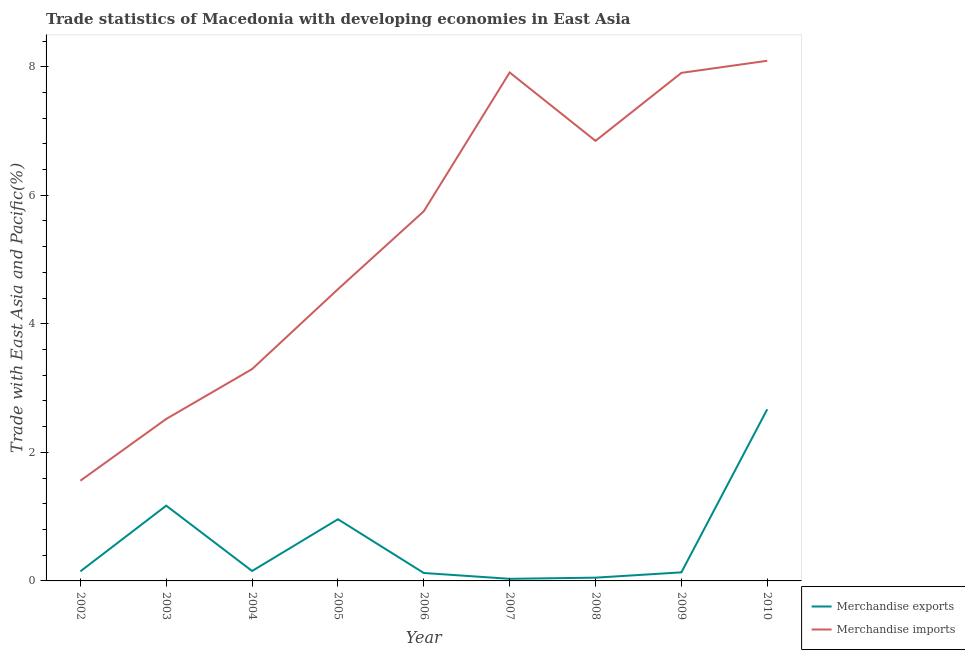How many different coloured lines are there?
Provide a short and direct response. 2. Does the line corresponding to merchandise exports intersect with the line corresponding to merchandise imports?
Your response must be concise. No. Is the number of lines equal to the number of legend labels?
Provide a succinct answer. Yes. What is the merchandise imports in 2009?
Your response must be concise. 7.9. Across all years, what is the maximum merchandise exports?
Your answer should be compact. 2.67. Across all years, what is the minimum merchandise imports?
Your answer should be compact. 1.56. In which year was the merchandise exports maximum?
Offer a terse response. 2010. What is the total merchandise exports in the graph?
Provide a succinct answer. 5.44. What is the difference between the merchandise exports in 2007 and that in 2008?
Offer a very short reply. -0.02. What is the difference between the merchandise imports in 2004 and the merchandise exports in 2010?
Provide a short and direct response. 0.62. What is the average merchandise exports per year?
Keep it short and to the point. 0.6. In the year 2009, what is the difference between the merchandise exports and merchandise imports?
Give a very brief answer. -7.77. In how many years, is the merchandise imports greater than 1.6 %?
Provide a short and direct response. 8. What is the ratio of the merchandise exports in 2004 to that in 2006?
Provide a succinct answer. 1.25. Is the merchandise imports in 2007 less than that in 2009?
Make the answer very short. No. Is the difference between the merchandise exports in 2005 and 2009 greater than the difference between the merchandise imports in 2005 and 2009?
Keep it short and to the point. Yes. What is the difference between the highest and the second highest merchandise imports?
Give a very brief answer. 0.18. What is the difference between the highest and the lowest merchandise exports?
Provide a succinct answer. 2.64. In how many years, is the merchandise imports greater than the average merchandise imports taken over all years?
Make the answer very short. 5. Is the sum of the merchandise imports in 2002 and 2010 greater than the maximum merchandise exports across all years?
Provide a succinct answer. Yes. Is the merchandise exports strictly greater than the merchandise imports over the years?
Your answer should be very brief. No. Is the merchandise exports strictly less than the merchandise imports over the years?
Your answer should be very brief. Yes. Are the values on the major ticks of Y-axis written in scientific E-notation?
Ensure brevity in your answer.  No. Does the graph contain any zero values?
Provide a succinct answer. No. Does the graph contain grids?
Your response must be concise. No. Where does the legend appear in the graph?
Give a very brief answer. Bottom right. What is the title of the graph?
Provide a succinct answer. Trade statistics of Macedonia with developing economies in East Asia. What is the label or title of the X-axis?
Make the answer very short. Year. What is the label or title of the Y-axis?
Keep it short and to the point. Trade with East Asia and Pacific(%). What is the Trade with East Asia and Pacific(%) in Merchandise exports in 2002?
Keep it short and to the point. 0.15. What is the Trade with East Asia and Pacific(%) in Merchandise imports in 2002?
Your response must be concise. 1.56. What is the Trade with East Asia and Pacific(%) of Merchandise exports in 2003?
Your response must be concise. 1.17. What is the Trade with East Asia and Pacific(%) in Merchandise imports in 2003?
Make the answer very short. 2.52. What is the Trade with East Asia and Pacific(%) of Merchandise exports in 2004?
Provide a succinct answer. 0.15. What is the Trade with East Asia and Pacific(%) in Merchandise imports in 2004?
Provide a succinct answer. 3.3. What is the Trade with East Asia and Pacific(%) in Merchandise exports in 2005?
Offer a very short reply. 0.96. What is the Trade with East Asia and Pacific(%) of Merchandise imports in 2005?
Provide a succinct answer. 4.54. What is the Trade with East Asia and Pacific(%) of Merchandise exports in 2006?
Ensure brevity in your answer.  0.12. What is the Trade with East Asia and Pacific(%) of Merchandise imports in 2006?
Provide a short and direct response. 5.75. What is the Trade with East Asia and Pacific(%) in Merchandise exports in 2007?
Keep it short and to the point. 0.03. What is the Trade with East Asia and Pacific(%) of Merchandise imports in 2007?
Provide a succinct answer. 7.91. What is the Trade with East Asia and Pacific(%) of Merchandise exports in 2008?
Ensure brevity in your answer.  0.05. What is the Trade with East Asia and Pacific(%) of Merchandise imports in 2008?
Make the answer very short. 6.85. What is the Trade with East Asia and Pacific(%) in Merchandise exports in 2009?
Keep it short and to the point. 0.13. What is the Trade with East Asia and Pacific(%) in Merchandise imports in 2009?
Your answer should be compact. 7.9. What is the Trade with East Asia and Pacific(%) in Merchandise exports in 2010?
Make the answer very short. 2.67. What is the Trade with East Asia and Pacific(%) of Merchandise imports in 2010?
Ensure brevity in your answer.  8.09. Across all years, what is the maximum Trade with East Asia and Pacific(%) in Merchandise exports?
Ensure brevity in your answer.  2.67. Across all years, what is the maximum Trade with East Asia and Pacific(%) of Merchandise imports?
Provide a short and direct response. 8.09. Across all years, what is the minimum Trade with East Asia and Pacific(%) in Merchandise exports?
Your answer should be very brief. 0.03. Across all years, what is the minimum Trade with East Asia and Pacific(%) in Merchandise imports?
Offer a terse response. 1.56. What is the total Trade with East Asia and Pacific(%) in Merchandise exports in the graph?
Provide a short and direct response. 5.44. What is the total Trade with East Asia and Pacific(%) of Merchandise imports in the graph?
Your response must be concise. 48.42. What is the difference between the Trade with East Asia and Pacific(%) of Merchandise exports in 2002 and that in 2003?
Provide a short and direct response. -1.02. What is the difference between the Trade with East Asia and Pacific(%) in Merchandise imports in 2002 and that in 2003?
Your response must be concise. -0.96. What is the difference between the Trade with East Asia and Pacific(%) in Merchandise exports in 2002 and that in 2004?
Provide a succinct answer. -0.01. What is the difference between the Trade with East Asia and Pacific(%) in Merchandise imports in 2002 and that in 2004?
Provide a short and direct response. -1.74. What is the difference between the Trade with East Asia and Pacific(%) in Merchandise exports in 2002 and that in 2005?
Make the answer very short. -0.81. What is the difference between the Trade with East Asia and Pacific(%) of Merchandise imports in 2002 and that in 2005?
Provide a short and direct response. -2.98. What is the difference between the Trade with East Asia and Pacific(%) of Merchandise exports in 2002 and that in 2006?
Offer a very short reply. 0.03. What is the difference between the Trade with East Asia and Pacific(%) of Merchandise imports in 2002 and that in 2006?
Offer a terse response. -4.19. What is the difference between the Trade with East Asia and Pacific(%) of Merchandise exports in 2002 and that in 2007?
Keep it short and to the point. 0.12. What is the difference between the Trade with East Asia and Pacific(%) in Merchandise imports in 2002 and that in 2007?
Provide a short and direct response. -6.35. What is the difference between the Trade with East Asia and Pacific(%) of Merchandise exports in 2002 and that in 2008?
Ensure brevity in your answer.  0.1. What is the difference between the Trade with East Asia and Pacific(%) of Merchandise imports in 2002 and that in 2008?
Ensure brevity in your answer.  -5.29. What is the difference between the Trade with East Asia and Pacific(%) of Merchandise exports in 2002 and that in 2009?
Offer a terse response. 0.02. What is the difference between the Trade with East Asia and Pacific(%) of Merchandise imports in 2002 and that in 2009?
Ensure brevity in your answer.  -6.35. What is the difference between the Trade with East Asia and Pacific(%) in Merchandise exports in 2002 and that in 2010?
Offer a very short reply. -2.52. What is the difference between the Trade with East Asia and Pacific(%) in Merchandise imports in 2002 and that in 2010?
Keep it short and to the point. -6.53. What is the difference between the Trade with East Asia and Pacific(%) in Merchandise exports in 2003 and that in 2004?
Your response must be concise. 1.02. What is the difference between the Trade with East Asia and Pacific(%) of Merchandise imports in 2003 and that in 2004?
Your response must be concise. -0.78. What is the difference between the Trade with East Asia and Pacific(%) of Merchandise exports in 2003 and that in 2005?
Make the answer very short. 0.21. What is the difference between the Trade with East Asia and Pacific(%) of Merchandise imports in 2003 and that in 2005?
Make the answer very short. -2.02. What is the difference between the Trade with East Asia and Pacific(%) of Merchandise exports in 2003 and that in 2006?
Make the answer very short. 1.05. What is the difference between the Trade with East Asia and Pacific(%) in Merchandise imports in 2003 and that in 2006?
Provide a short and direct response. -3.23. What is the difference between the Trade with East Asia and Pacific(%) in Merchandise exports in 2003 and that in 2007?
Offer a very short reply. 1.14. What is the difference between the Trade with East Asia and Pacific(%) in Merchandise imports in 2003 and that in 2007?
Ensure brevity in your answer.  -5.39. What is the difference between the Trade with East Asia and Pacific(%) in Merchandise exports in 2003 and that in 2008?
Make the answer very short. 1.12. What is the difference between the Trade with East Asia and Pacific(%) of Merchandise imports in 2003 and that in 2008?
Your answer should be very brief. -4.33. What is the difference between the Trade with East Asia and Pacific(%) in Merchandise exports in 2003 and that in 2009?
Offer a terse response. 1.04. What is the difference between the Trade with East Asia and Pacific(%) in Merchandise imports in 2003 and that in 2009?
Ensure brevity in your answer.  -5.38. What is the difference between the Trade with East Asia and Pacific(%) of Merchandise exports in 2003 and that in 2010?
Keep it short and to the point. -1.5. What is the difference between the Trade with East Asia and Pacific(%) of Merchandise imports in 2003 and that in 2010?
Ensure brevity in your answer.  -5.57. What is the difference between the Trade with East Asia and Pacific(%) of Merchandise exports in 2004 and that in 2005?
Provide a short and direct response. -0.81. What is the difference between the Trade with East Asia and Pacific(%) of Merchandise imports in 2004 and that in 2005?
Give a very brief answer. -1.24. What is the difference between the Trade with East Asia and Pacific(%) in Merchandise exports in 2004 and that in 2006?
Provide a succinct answer. 0.03. What is the difference between the Trade with East Asia and Pacific(%) of Merchandise imports in 2004 and that in 2006?
Your response must be concise. -2.46. What is the difference between the Trade with East Asia and Pacific(%) in Merchandise exports in 2004 and that in 2007?
Provide a short and direct response. 0.12. What is the difference between the Trade with East Asia and Pacific(%) of Merchandise imports in 2004 and that in 2007?
Ensure brevity in your answer.  -4.61. What is the difference between the Trade with East Asia and Pacific(%) of Merchandise exports in 2004 and that in 2008?
Give a very brief answer. 0.1. What is the difference between the Trade with East Asia and Pacific(%) in Merchandise imports in 2004 and that in 2008?
Offer a terse response. -3.55. What is the difference between the Trade with East Asia and Pacific(%) of Merchandise exports in 2004 and that in 2009?
Ensure brevity in your answer.  0.02. What is the difference between the Trade with East Asia and Pacific(%) of Merchandise imports in 2004 and that in 2009?
Your answer should be very brief. -4.61. What is the difference between the Trade with East Asia and Pacific(%) of Merchandise exports in 2004 and that in 2010?
Make the answer very short. -2.52. What is the difference between the Trade with East Asia and Pacific(%) in Merchandise imports in 2004 and that in 2010?
Keep it short and to the point. -4.8. What is the difference between the Trade with East Asia and Pacific(%) of Merchandise exports in 2005 and that in 2006?
Offer a terse response. 0.84. What is the difference between the Trade with East Asia and Pacific(%) in Merchandise imports in 2005 and that in 2006?
Give a very brief answer. -1.21. What is the difference between the Trade with East Asia and Pacific(%) of Merchandise exports in 2005 and that in 2007?
Ensure brevity in your answer.  0.93. What is the difference between the Trade with East Asia and Pacific(%) in Merchandise imports in 2005 and that in 2007?
Keep it short and to the point. -3.37. What is the difference between the Trade with East Asia and Pacific(%) of Merchandise exports in 2005 and that in 2008?
Your answer should be compact. 0.91. What is the difference between the Trade with East Asia and Pacific(%) of Merchandise imports in 2005 and that in 2008?
Give a very brief answer. -2.31. What is the difference between the Trade with East Asia and Pacific(%) of Merchandise exports in 2005 and that in 2009?
Your answer should be compact. 0.83. What is the difference between the Trade with East Asia and Pacific(%) in Merchandise imports in 2005 and that in 2009?
Give a very brief answer. -3.37. What is the difference between the Trade with East Asia and Pacific(%) in Merchandise exports in 2005 and that in 2010?
Offer a terse response. -1.71. What is the difference between the Trade with East Asia and Pacific(%) in Merchandise imports in 2005 and that in 2010?
Provide a succinct answer. -3.55. What is the difference between the Trade with East Asia and Pacific(%) in Merchandise exports in 2006 and that in 2007?
Provide a short and direct response. 0.09. What is the difference between the Trade with East Asia and Pacific(%) of Merchandise imports in 2006 and that in 2007?
Keep it short and to the point. -2.16. What is the difference between the Trade with East Asia and Pacific(%) in Merchandise exports in 2006 and that in 2008?
Ensure brevity in your answer.  0.07. What is the difference between the Trade with East Asia and Pacific(%) of Merchandise imports in 2006 and that in 2008?
Your response must be concise. -1.1. What is the difference between the Trade with East Asia and Pacific(%) of Merchandise exports in 2006 and that in 2009?
Give a very brief answer. -0.01. What is the difference between the Trade with East Asia and Pacific(%) in Merchandise imports in 2006 and that in 2009?
Offer a terse response. -2.15. What is the difference between the Trade with East Asia and Pacific(%) of Merchandise exports in 2006 and that in 2010?
Keep it short and to the point. -2.55. What is the difference between the Trade with East Asia and Pacific(%) of Merchandise imports in 2006 and that in 2010?
Your answer should be compact. -2.34. What is the difference between the Trade with East Asia and Pacific(%) in Merchandise exports in 2007 and that in 2008?
Offer a very short reply. -0.02. What is the difference between the Trade with East Asia and Pacific(%) in Merchandise imports in 2007 and that in 2008?
Give a very brief answer. 1.06. What is the difference between the Trade with East Asia and Pacific(%) in Merchandise exports in 2007 and that in 2009?
Keep it short and to the point. -0.1. What is the difference between the Trade with East Asia and Pacific(%) of Merchandise imports in 2007 and that in 2009?
Provide a short and direct response. 0.01. What is the difference between the Trade with East Asia and Pacific(%) of Merchandise exports in 2007 and that in 2010?
Provide a short and direct response. -2.64. What is the difference between the Trade with East Asia and Pacific(%) of Merchandise imports in 2007 and that in 2010?
Your answer should be compact. -0.18. What is the difference between the Trade with East Asia and Pacific(%) of Merchandise exports in 2008 and that in 2009?
Offer a very short reply. -0.08. What is the difference between the Trade with East Asia and Pacific(%) of Merchandise imports in 2008 and that in 2009?
Your response must be concise. -1.06. What is the difference between the Trade with East Asia and Pacific(%) in Merchandise exports in 2008 and that in 2010?
Offer a terse response. -2.62. What is the difference between the Trade with East Asia and Pacific(%) of Merchandise imports in 2008 and that in 2010?
Your answer should be very brief. -1.25. What is the difference between the Trade with East Asia and Pacific(%) of Merchandise exports in 2009 and that in 2010?
Your answer should be compact. -2.54. What is the difference between the Trade with East Asia and Pacific(%) in Merchandise imports in 2009 and that in 2010?
Your response must be concise. -0.19. What is the difference between the Trade with East Asia and Pacific(%) in Merchandise exports in 2002 and the Trade with East Asia and Pacific(%) in Merchandise imports in 2003?
Offer a very short reply. -2.37. What is the difference between the Trade with East Asia and Pacific(%) in Merchandise exports in 2002 and the Trade with East Asia and Pacific(%) in Merchandise imports in 2004?
Your answer should be compact. -3.15. What is the difference between the Trade with East Asia and Pacific(%) of Merchandise exports in 2002 and the Trade with East Asia and Pacific(%) of Merchandise imports in 2005?
Provide a short and direct response. -4.39. What is the difference between the Trade with East Asia and Pacific(%) in Merchandise exports in 2002 and the Trade with East Asia and Pacific(%) in Merchandise imports in 2006?
Offer a terse response. -5.6. What is the difference between the Trade with East Asia and Pacific(%) of Merchandise exports in 2002 and the Trade with East Asia and Pacific(%) of Merchandise imports in 2007?
Give a very brief answer. -7.76. What is the difference between the Trade with East Asia and Pacific(%) of Merchandise exports in 2002 and the Trade with East Asia and Pacific(%) of Merchandise imports in 2008?
Offer a very short reply. -6.7. What is the difference between the Trade with East Asia and Pacific(%) in Merchandise exports in 2002 and the Trade with East Asia and Pacific(%) in Merchandise imports in 2009?
Offer a terse response. -7.76. What is the difference between the Trade with East Asia and Pacific(%) in Merchandise exports in 2002 and the Trade with East Asia and Pacific(%) in Merchandise imports in 2010?
Keep it short and to the point. -7.94. What is the difference between the Trade with East Asia and Pacific(%) in Merchandise exports in 2003 and the Trade with East Asia and Pacific(%) in Merchandise imports in 2004?
Your answer should be very brief. -2.12. What is the difference between the Trade with East Asia and Pacific(%) in Merchandise exports in 2003 and the Trade with East Asia and Pacific(%) in Merchandise imports in 2005?
Keep it short and to the point. -3.37. What is the difference between the Trade with East Asia and Pacific(%) in Merchandise exports in 2003 and the Trade with East Asia and Pacific(%) in Merchandise imports in 2006?
Keep it short and to the point. -4.58. What is the difference between the Trade with East Asia and Pacific(%) in Merchandise exports in 2003 and the Trade with East Asia and Pacific(%) in Merchandise imports in 2007?
Your response must be concise. -6.74. What is the difference between the Trade with East Asia and Pacific(%) in Merchandise exports in 2003 and the Trade with East Asia and Pacific(%) in Merchandise imports in 2008?
Give a very brief answer. -5.68. What is the difference between the Trade with East Asia and Pacific(%) in Merchandise exports in 2003 and the Trade with East Asia and Pacific(%) in Merchandise imports in 2009?
Your answer should be very brief. -6.73. What is the difference between the Trade with East Asia and Pacific(%) in Merchandise exports in 2003 and the Trade with East Asia and Pacific(%) in Merchandise imports in 2010?
Provide a short and direct response. -6.92. What is the difference between the Trade with East Asia and Pacific(%) of Merchandise exports in 2004 and the Trade with East Asia and Pacific(%) of Merchandise imports in 2005?
Your answer should be very brief. -4.38. What is the difference between the Trade with East Asia and Pacific(%) in Merchandise exports in 2004 and the Trade with East Asia and Pacific(%) in Merchandise imports in 2006?
Give a very brief answer. -5.6. What is the difference between the Trade with East Asia and Pacific(%) in Merchandise exports in 2004 and the Trade with East Asia and Pacific(%) in Merchandise imports in 2007?
Provide a short and direct response. -7.76. What is the difference between the Trade with East Asia and Pacific(%) in Merchandise exports in 2004 and the Trade with East Asia and Pacific(%) in Merchandise imports in 2008?
Offer a terse response. -6.69. What is the difference between the Trade with East Asia and Pacific(%) in Merchandise exports in 2004 and the Trade with East Asia and Pacific(%) in Merchandise imports in 2009?
Your answer should be compact. -7.75. What is the difference between the Trade with East Asia and Pacific(%) in Merchandise exports in 2004 and the Trade with East Asia and Pacific(%) in Merchandise imports in 2010?
Provide a succinct answer. -7.94. What is the difference between the Trade with East Asia and Pacific(%) of Merchandise exports in 2005 and the Trade with East Asia and Pacific(%) of Merchandise imports in 2006?
Your answer should be very brief. -4.79. What is the difference between the Trade with East Asia and Pacific(%) in Merchandise exports in 2005 and the Trade with East Asia and Pacific(%) in Merchandise imports in 2007?
Offer a very short reply. -6.95. What is the difference between the Trade with East Asia and Pacific(%) of Merchandise exports in 2005 and the Trade with East Asia and Pacific(%) of Merchandise imports in 2008?
Ensure brevity in your answer.  -5.89. What is the difference between the Trade with East Asia and Pacific(%) of Merchandise exports in 2005 and the Trade with East Asia and Pacific(%) of Merchandise imports in 2009?
Your answer should be compact. -6.94. What is the difference between the Trade with East Asia and Pacific(%) of Merchandise exports in 2005 and the Trade with East Asia and Pacific(%) of Merchandise imports in 2010?
Give a very brief answer. -7.13. What is the difference between the Trade with East Asia and Pacific(%) of Merchandise exports in 2006 and the Trade with East Asia and Pacific(%) of Merchandise imports in 2007?
Provide a short and direct response. -7.79. What is the difference between the Trade with East Asia and Pacific(%) of Merchandise exports in 2006 and the Trade with East Asia and Pacific(%) of Merchandise imports in 2008?
Your answer should be compact. -6.72. What is the difference between the Trade with East Asia and Pacific(%) of Merchandise exports in 2006 and the Trade with East Asia and Pacific(%) of Merchandise imports in 2009?
Ensure brevity in your answer.  -7.78. What is the difference between the Trade with East Asia and Pacific(%) in Merchandise exports in 2006 and the Trade with East Asia and Pacific(%) in Merchandise imports in 2010?
Your answer should be compact. -7.97. What is the difference between the Trade with East Asia and Pacific(%) of Merchandise exports in 2007 and the Trade with East Asia and Pacific(%) of Merchandise imports in 2008?
Your response must be concise. -6.81. What is the difference between the Trade with East Asia and Pacific(%) in Merchandise exports in 2007 and the Trade with East Asia and Pacific(%) in Merchandise imports in 2009?
Ensure brevity in your answer.  -7.87. What is the difference between the Trade with East Asia and Pacific(%) of Merchandise exports in 2007 and the Trade with East Asia and Pacific(%) of Merchandise imports in 2010?
Make the answer very short. -8.06. What is the difference between the Trade with East Asia and Pacific(%) in Merchandise exports in 2008 and the Trade with East Asia and Pacific(%) in Merchandise imports in 2009?
Ensure brevity in your answer.  -7.85. What is the difference between the Trade with East Asia and Pacific(%) of Merchandise exports in 2008 and the Trade with East Asia and Pacific(%) of Merchandise imports in 2010?
Provide a short and direct response. -8.04. What is the difference between the Trade with East Asia and Pacific(%) of Merchandise exports in 2009 and the Trade with East Asia and Pacific(%) of Merchandise imports in 2010?
Keep it short and to the point. -7.96. What is the average Trade with East Asia and Pacific(%) in Merchandise exports per year?
Your answer should be compact. 0.6. What is the average Trade with East Asia and Pacific(%) in Merchandise imports per year?
Provide a short and direct response. 5.38. In the year 2002, what is the difference between the Trade with East Asia and Pacific(%) of Merchandise exports and Trade with East Asia and Pacific(%) of Merchandise imports?
Provide a short and direct response. -1.41. In the year 2003, what is the difference between the Trade with East Asia and Pacific(%) of Merchandise exports and Trade with East Asia and Pacific(%) of Merchandise imports?
Offer a very short reply. -1.35. In the year 2004, what is the difference between the Trade with East Asia and Pacific(%) in Merchandise exports and Trade with East Asia and Pacific(%) in Merchandise imports?
Ensure brevity in your answer.  -3.14. In the year 2005, what is the difference between the Trade with East Asia and Pacific(%) in Merchandise exports and Trade with East Asia and Pacific(%) in Merchandise imports?
Your answer should be compact. -3.58. In the year 2006, what is the difference between the Trade with East Asia and Pacific(%) of Merchandise exports and Trade with East Asia and Pacific(%) of Merchandise imports?
Provide a short and direct response. -5.63. In the year 2007, what is the difference between the Trade with East Asia and Pacific(%) in Merchandise exports and Trade with East Asia and Pacific(%) in Merchandise imports?
Your answer should be very brief. -7.88. In the year 2008, what is the difference between the Trade with East Asia and Pacific(%) of Merchandise exports and Trade with East Asia and Pacific(%) of Merchandise imports?
Your answer should be very brief. -6.8. In the year 2009, what is the difference between the Trade with East Asia and Pacific(%) of Merchandise exports and Trade with East Asia and Pacific(%) of Merchandise imports?
Offer a terse response. -7.77. In the year 2010, what is the difference between the Trade with East Asia and Pacific(%) of Merchandise exports and Trade with East Asia and Pacific(%) of Merchandise imports?
Offer a terse response. -5.42. What is the ratio of the Trade with East Asia and Pacific(%) of Merchandise exports in 2002 to that in 2003?
Ensure brevity in your answer.  0.13. What is the ratio of the Trade with East Asia and Pacific(%) in Merchandise imports in 2002 to that in 2003?
Your answer should be compact. 0.62. What is the ratio of the Trade with East Asia and Pacific(%) in Merchandise exports in 2002 to that in 2004?
Offer a very short reply. 0.96. What is the ratio of the Trade with East Asia and Pacific(%) of Merchandise imports in 2002 to that in 2004?
Provide a short and direct response. 0.47. What is the ratio of the Trade with East Asia and Pacific(%) of Merchandise exports in 2002 to that in 2005?
Your response must be concise. 0.15. What is the ratio of the Trade with East Asia and Pacific(%) in Merchandise imports in 2002 to that in 2005?
Give a very brief answer. 0.34. What is the ratio of the Trade with East Asia and Pacific(%) in Merchandise exports in 2002 to that in 2006?
Ensure brevity in your answer.  1.21. What is the ratio of the Trade with East Asia and Pacific(%) of Merchandise imports in 2002 to that in 2006?
Your response must be concise. 0.27. What is the ratio of the Trade with East Asia and Pacific(%) in Merchandise exports in 2002 to that in 2007?
Your answer should be compact. 4.54. What is the ratio of the Trade with East Asia and Pacific(%) of Merchandise imports in 2002 to that in 2007?
Ensure brevity in your answer.  0.2. What is the ratio of the Trade with East Asia and Pacific(%) of Merchandise exports in 2002 to that in 2008?
Ensure brevity in your answer.  2.92. What is the ratio of the Trade with East Asia and Pacific(%) in Merchandise imports in 2002 to that in 2008?
Provide a succinct answer. 0.23. What is the ratio of the Trade with East Asia and Pacific(%) in Merchandise exports in 2002 to that in 2009?
Your response must be concise. 1.12. What is the ratio of the Trade with East Asia and Pacific(%) in Merchandise imports in 2002 to that in 2009?
Provide a short and direct response. 0.2. What is the ratio of the Trade with East Asia and Pacific(%) of Merchandise exports in 2002 to that in 2010?
Give a very brief answer. 0.06. What is the ratio of the Trade with East Asia and Pacific(%) of Merchandise imports in 2002 to that in 2010?
Give a very brief answer. 0.19. What is the ratio of the Trade with East Asia and Pacific(%) in Merchandise exports in 2003 to that in 2004?
Offer a terse response. 7.58. What is the ratio of the Trade with East Asia and Pacific(%) of Merchandise imports in 2003 to that in 2004?
Provide a succinct answer. 0.76. What is the ratio of the Trade with East Asia and Pacific(%) in Merchandise exports in 2003 to that in 2005?
Your answer should be compact. 1.22. What is the ratio of the Trade with East Asia and Pacific(%) in Merchandise imports in 2003 to that in 2005?
Make the answer very short. 0.56. What is the ratio of the Trade with East Asia and Pacific(%) in Merchandise exports in 2003 to that in 2006?
Provide a short and direct response. 9.49. What is the ratio of the Trade with East Asia and Pacific(%) in Merchandise imports in 2003 to that in 2006?
Offer a terse response. 0.44. What is the ratio of the Trade with East Asia and Pacific(%) of Merchandise exports in 2003 to that in 2007?
Your response must be concise. 35.77. What is the ratio of the Trade with East Asia and Pacific(%) in Merchandise imports in 2003 to that in 2007?
Provide a short and direct response. 0.32. What is the ratio of the Trade with East Asia and Pacific(%) in Merchandise exports in 2003 to that in 2008?
Your answer should be compact. 23.03. What is the ratio of the Trade with East Asia and Pacific(%) in Merchandise imports in 2003 to that in 2008?
Your response must be concise. 0.37. What is the ratio of the Trade with East Asia and Pacific(%) of Merchandise exports in 2003 to that in 2009?
Ensure brevity in your answer.  8.79. What is the ratio of the Trade with East Asia and Pacific(%) of Merchandise imports in 2003 to that in 2009?
Make the answer very short. 0.32. What is the ratio of the Trade with East Asia and Pacific(%) in Merchandise exports in 2003 to that in 2010?
Keep it short and to the point. 0.44. What is the ratio of the Trade with East Asia and Pacific(%) in Merchandise imports in 2003 to that in 2010?
Offer a terse response. 0.31. What is the ratio of the Trade with East Asia and Pacific(%) in Merchandise exports in 2004 to that in 2005?
Your answer should be compact. 0.16. What is the ratio of the Trade with East Asia and Pacific(%) in Merchandise imports in 2004 to that in 2005?
Ensure brevity in your answer.  0.73. What is the ratio of the Trade with East Asia and Pacific(%) in Merchandise exports in 2004 to that in 2006?
Offer a very short reply. 1.25. What is the ratio of the Trade with East Asia and Pacific(%) of Merchandise imports in 2004 to that in 2006?
Ensure brevity in your answer.  0.57. What is the ratio of the Trade with East Asia and Pacific(%) of Merchandise exports in 2004 to that in 2007?
Offer a terse response. 4.72. What is the ratio of the Trade with East Asia and Pacific(%) in Merchandise imports in 2004 to that in 2007?
Your response must be concise. 0.42. What is the ratio of the Trade with East Asia and Pacific(%) of Merchandise exports in 2004 to that in 2008?
Your answer should be compact. 3.04. What is the ratio of the Trade with East Asia and Pacific(%) in Merchandise imports in 2004 to that in 2008?
Provide a succinct answer. 0.48. What is the ratio of the Trade with East Asia and Pacific(%) in Merchandise exports in 2004 to that in 2009?
Offer a very short reply. 1.16. What is the ratio of the Trade with East Asia and Pacific(%) of Merchandise imports in 2004 to that in 2009?
Your answer should be compact. 0.42. What is the ratio of the Trade with East Asia and Pacific(%) in Merchandise exports in 2004 to that in 2010?
Give a very brief answer. 0.06. What is the ratio of the Trade with East Asia and Pacific(%) of Merchandise imports in 2004 to that in 2010?
Offer a terse response. 0.41. What is the ratio of the Trade with East Asia and Pacific(%) of Merchandise exports in 2005 to that in 2006?
Your answer should be compact. 7.78. What is the ratio of the Trade with East Asia and Pacific(%) of Merchandise imports in 2005 to that in 2006?
Provide a short and direct response. 0.79. What is the ratio of the Trade with East Asia and Pacific(%) in Merchandise exports in 2005 to that in 2007?
Ensure brevity in your answer.  29.32. What is the ratio of the Trade with East Asia and Pacific(%) of Merchandise imports in 2005 to that in 2007?
Provide a short and direct response. 0.57. What is the ratio of the Trade with East Asia and Pacific(%) of Merchandise exports in 2005 to that in 2008?
Your answer should be very brief. 18.87. What is the ratio of the Trade with East Asia and Pacific(%) of Merchandise imports in 2005 to that in 2008?
Your response must be concise. 0.66. What is the ratio of the Trade with East Asia and Pacific(%) in Merchandise exports in 2005 to that in 2009?
Your answer should be very brief. 7.2. What is the ratio of the Trade with East Asia and Pacific(%) of Merchandise imports in 2005 to that in 2009?
Give a very brief answer. 0.57. What is the ratio of the Trade with East Asia and Pacific(%) in Merchandise exports in 2005 to that in 2010?
Make the answer very short. 0.36. What is the ratio of the Trade with East Asia and Pacific(%) of Merchandise imports in 2005 to that in 2010?
Your answer should be very brief. 0.56. What is the ratio of the Trade with East Asia and Pacific(%) of Merchandise exports in 2006 to that in 2007?
Your answer should be compact. 3.77. What is the ratio of the Trade with East Asia and Pacific(%) of Merchandise imports in 2006 to that in 2007?
Keep it short and to the point. 0.73. What is the ratio of the Trade with East Asia and Pacific(%) in Merchandise exports in 2006 to that in 2008?
Your answer should be compact. 2.43. What is the ratio of the Trade with East Asia and Pacific(%) in Merchandise imports in 2006 to that in 2008?
Offer a terse response. 0.84. What is the ratio of the Trade with East Asia and Pacific(%) in Merchandise exports in 2006 to that in 2009?
Ensure brevity in your answer.  0.93. What is the ratio of the Trade with East Asia and Pacific(%) in Merchandise imports in 2006 to that in 2009?
Ensure brevity in your answer.  0.73. What is the ratio of the Trade with East Asia and Pacific(%) of Merchandise exports in 2006 to that in 2010?
Offer a very short reply. 0.05. What is the ratio of the Trade with East Asia and Pacific(%) of Merchandise imports in 2006 to that in 2010?
Your response must be concise. 0.71. What is the ratio of the Trade with East Asia and Pacific(%) of Merchandise exports in 2007 to that in 2008?
Your answer should be compact. 0.64. What is the ratio of the Trade with East Asia and Pacific(%) in Merchandise imports in 2007 to that in 2008?
Ensure brevity in your answer.  1.16. What is the ratio of the Trade with East Asia and Pacific(%) of Merchandise exports in 2007 to that in 2009?
Provide a short and direct response. 0.25. What is the ratio of the Trade with East Asia and Pacific(%) of Merchandise exports in 2007 to that in 2010?
Give a very brief answer. 0.01. What is the ratio of the Trade with East Asia and Pacific(%) of Merchandise imports in 2007 to that in 2010?
Offer a very short reply. 0.98. What is the ratio of the Trade with East Asia and Pacific(%) in Merchandise exports in 2008 to that in 2009?
Provide a succinct answer. 0.38. What is the ratio of the Trade with East Asia and Pacific(%) in Merchandise imports in 2008 to that in 2009?
Your answer should be compact. 0.87. What is the ratio of the Trade with East Asia and Pacific(%) in Merchandise exports in 2008 to that in 2010?
Give a very brief answer. 0.02. What is the ratio of the Trade with East Asia and Pacific(%) of Merchandise imports in 2008 to that in 2010?
Keep it short and to the point. 0.85. What is the ratio of the Trade with East Asia and Pacific(%) in Merchandise exports in 2009 to that in 2010?
Keep it short and to the point. 0.05. What is the ratio of the Trade with East Asia and Pacific(%) of Merchandise imports in 2009 to that in 2010?
Ensure brevity in your answer.  0.98. What is the difference between the highest and the second highest Trade with East Asia and Pacific(%) in Merchandise exports?
Your answer should be very brief. 1.5. What is the difference between the highest and the second highest Trade with East Asia and Pacific(%) in Merchandise imports?
Your answer should be very brief. 0.18. What is the difference between the highest and the lowest Trade with East Asia and Pacific(%) in Merchandise exports?
Provide a succinct answer. 2.64. What is the difference between the highest and the lowest Trade with East Asia and Pacific(%) in Merchandise imports?
Ensure brevity in your answer.  6.53. 